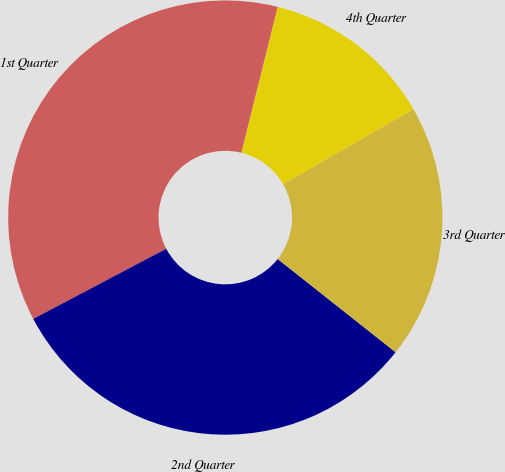<chart> <loc_0><loc_0><loc_500><loc_500><pie_chart><fcel>1st Quarter<fcel>2nd Quarter<fcel>3rd Quarter<fcel>4th Quarter<nl><fcel>36.61%<fcel>31.62%<fcel>18.97%<fcel>12.79%<nl></chart> 